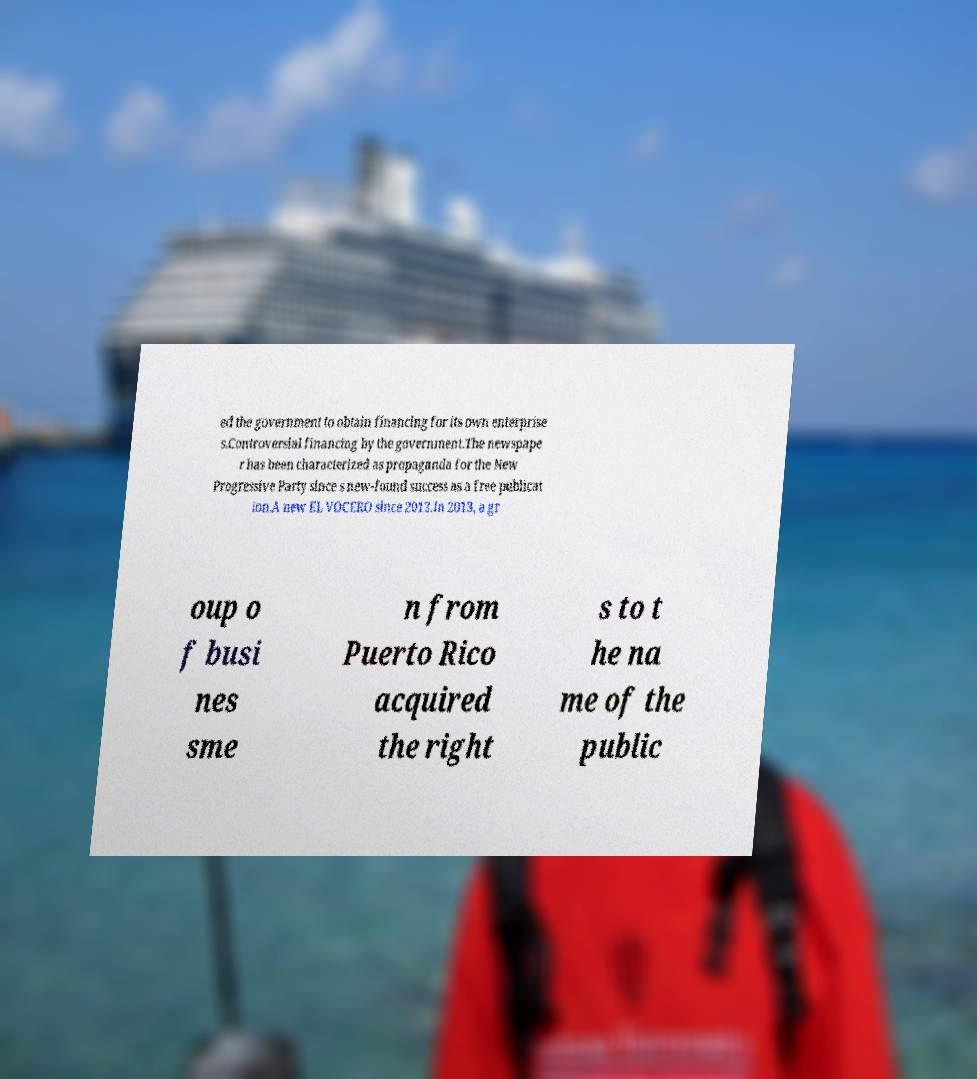Could you assist in decoding the text presented in this image and type it out clearly? ed the government to obtain financing for its own enterprise s.Controversial financing by the government.The newspape r has been characterized as propaganda for the New Progressive Party since s new-found success as a free publicat ion.A new EL VOCERO since 2013.In 2013, a gr oup o f busi nes sme n from Puerto Rico acquired the right s to t he na me of the public 